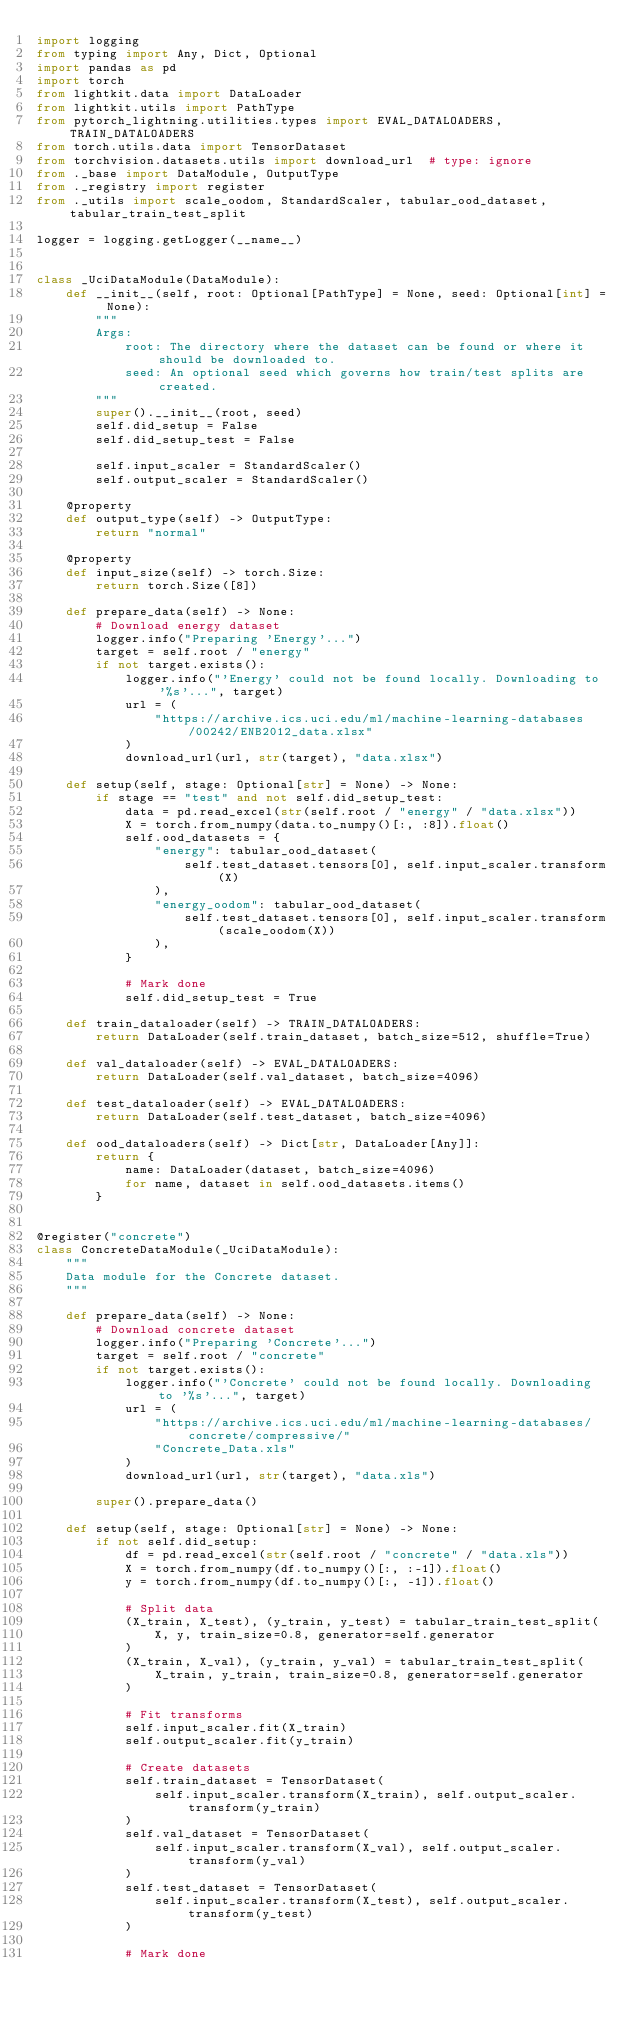Convert code to text. <code><loc_0><loc_0><loc_500><loc_500><_Python_>import logging
from typing import Any, Dict, Optional
import pandas as pd
import torch
from lightkit.data import DataLoader
from lightkit.utils import PathType
from pytorch_lightning.utilities.types import EVAL_DATALOADERS, TRAIN_DATALOADERS
from torch.utils.data import TensorDataset
from torchvision.datasets.utils import download_url  # type: ignore
from ._base import DataModule, OutputType
from ._registry import register
from ._utils import scale_oodom, StandardScaler, tabular_ood_dataset, tabular_train_test_split

logger = logging.getLogger(__name__)


class _UciDataModule(DataModule):
    def __init__(self, root: Optional[PathType] = None, seed: Optional[int] = None):
        """
        Args:
            root: The directory where the dataset can be found or where it should be downloaded to.
            seed: An optional seed which governs how train/test splits are created.
        """
        super().__init__(root, seed)
        self.did_setup = False
        self.did_setup_test = False

        self.input_scaler = StandardScaler()
        self.output_scaler = StandardScaler()

    @property
    def output_type(self) -> OutputType:
        return "normal"

    @property
    def input_size(self) -> torch.Size:
        return torch.Size([8])

    def prepare_data(self) -> None:
        # Download energy dataset
        logger.info("Preparing 'Energy'...")
        target = self.root / "energy"
        if not target.exists():
            logger.info("'Energy' could not be found locally. Downloading to '%s'...", target)
            url = (
                "https://archive.ics.uci.edu/ml/machine-learning-databases/00242/ENB2012_data.xlsx"
            )
            download_url(url, str(target), "data.xlsx")

    def setup(self, stage: Optional[str] = None) -> None:
        if stage == "test" and not self.did_setup_test:
            data = pd.read_excel(str(self.root / "energy" / "data.xlsx"))
            X = torch.from_numpy(data.to_numpy()[:, :8]).float()
            self.ood_datasets = {
                "energy": tabular_ood_dataset(
                    self.test_dataset.tensors[0], self.input_scaler.transform(X)
                ),
                "energy_oodom": tabular_ood_dataset(
                    self.test_dataset.tensors[0], self.input_scaler.transform(scale_oodom(X))
                ),
            }

            # Mark done
            self.did_setup_test = True

    def train_dataloader(self) -> TRAIN_DATALOADERS:
        return DataLoader(self.train_dataset, batch_size=512, shuffle=True)

    def val_dataloader(self) -> EVAL_DATALOADERS:
        return DataLoader(self.val_dataset, batch_size=4096)

    def test_dataloader(self) -> EVAL_DATALOADERS:
        return DataLoader(self.test_dataset, batch_size=4096)

    def ood_dataloaders(self) -> Dict[str, DataLoader[Any]]:
        return {
            name: DataLoader(dataset, batch_size=4096)
            for name, dataset in self.ood_datasets.items()
        }


@register("concrete")
class ConcreteDataModule(_UciDataModule):
    """
    Data module for the Concrete dataset.
    """

    def prepare_data(self) -> None:
        # Download concrete dataset
        logger.info("Preparing 'Concrete'...")
        target = self.root / "concrete"
        if not target.exists():
            logger.info("'Concrete' could not be found locally. Downloading to '%s'...", target)
            url = (
                "https://archive.ics.uci.edu/ml/machine-learning-databases/concrete/compressive/"
                "Concrete_Data.xls"
            )
            download_url(url, str(target), "data.xls")

        super().prepare_data()

    def setup(self, stage: Optional[str] = None) -> None:
        if not self.did_setup:
            df = pd.read_excel(str(self.root / "concrete" / "data.xls"))
            X = torch.from_numpy(df.to_numpy()[:, :-1]).float()
            y = torch.from_numpy(df.to_numpy()[:, -1]).float()

            # Split data
            (X_train, X_test), (y_train, y_test) = tabular_train_test_split(
                X, y, train_size=0.8, generator=self.generator
            )
            (X_train, X_val), (y_train, y_val) = tabular_train_test_split(
                X_train, y_train, train_size=0.8, generator=self.generator
            )

            # Fit transforms
            self.input_scaler.fit(X_train)
            self.output_scaler.fit(y_train)

            # Create datasets
            self.train_dataset = TensorDataset(
                self.input_scaler.transform(X_train), self.output_scaler.transform(y_train)
            )
            self.val_dataset = TensorDataset(
                self.input_scaler.transform(X_val), self.output_scaler.transform(y_val)
            )
            self.test_dataset = TensorDataset(
                self.input_scaler.transform(X_test), self.output_scaler.transform(y_test)
            )

            # Mark done</code> 